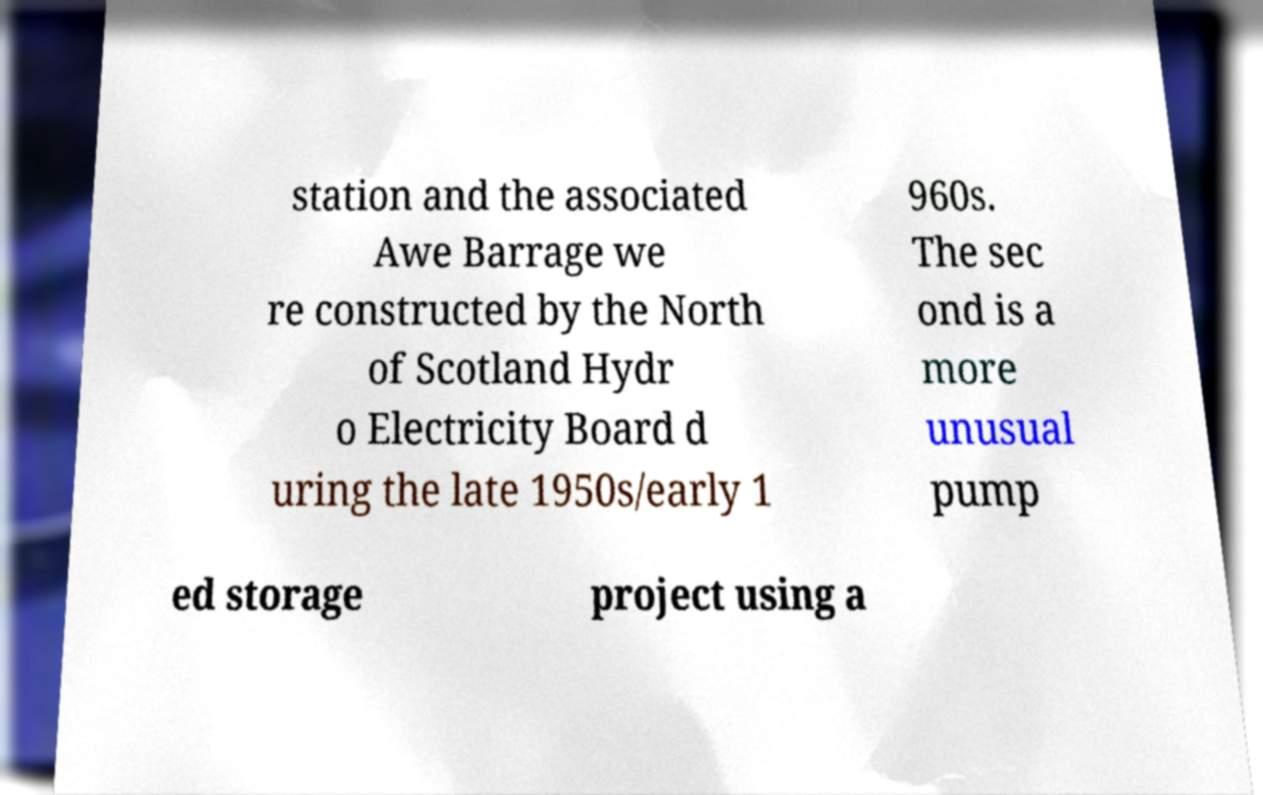Can you read and provide the text displayed in the image?This photo seems to have some interesting text. Can you extract and type it out for me? station and the associated Awe Barrage we re constructed by the North of Scotland Hydr o Electricity Board d uring the late 1950s/early 1 960s. The sec ond is a more unusual pump ed storage project using a 